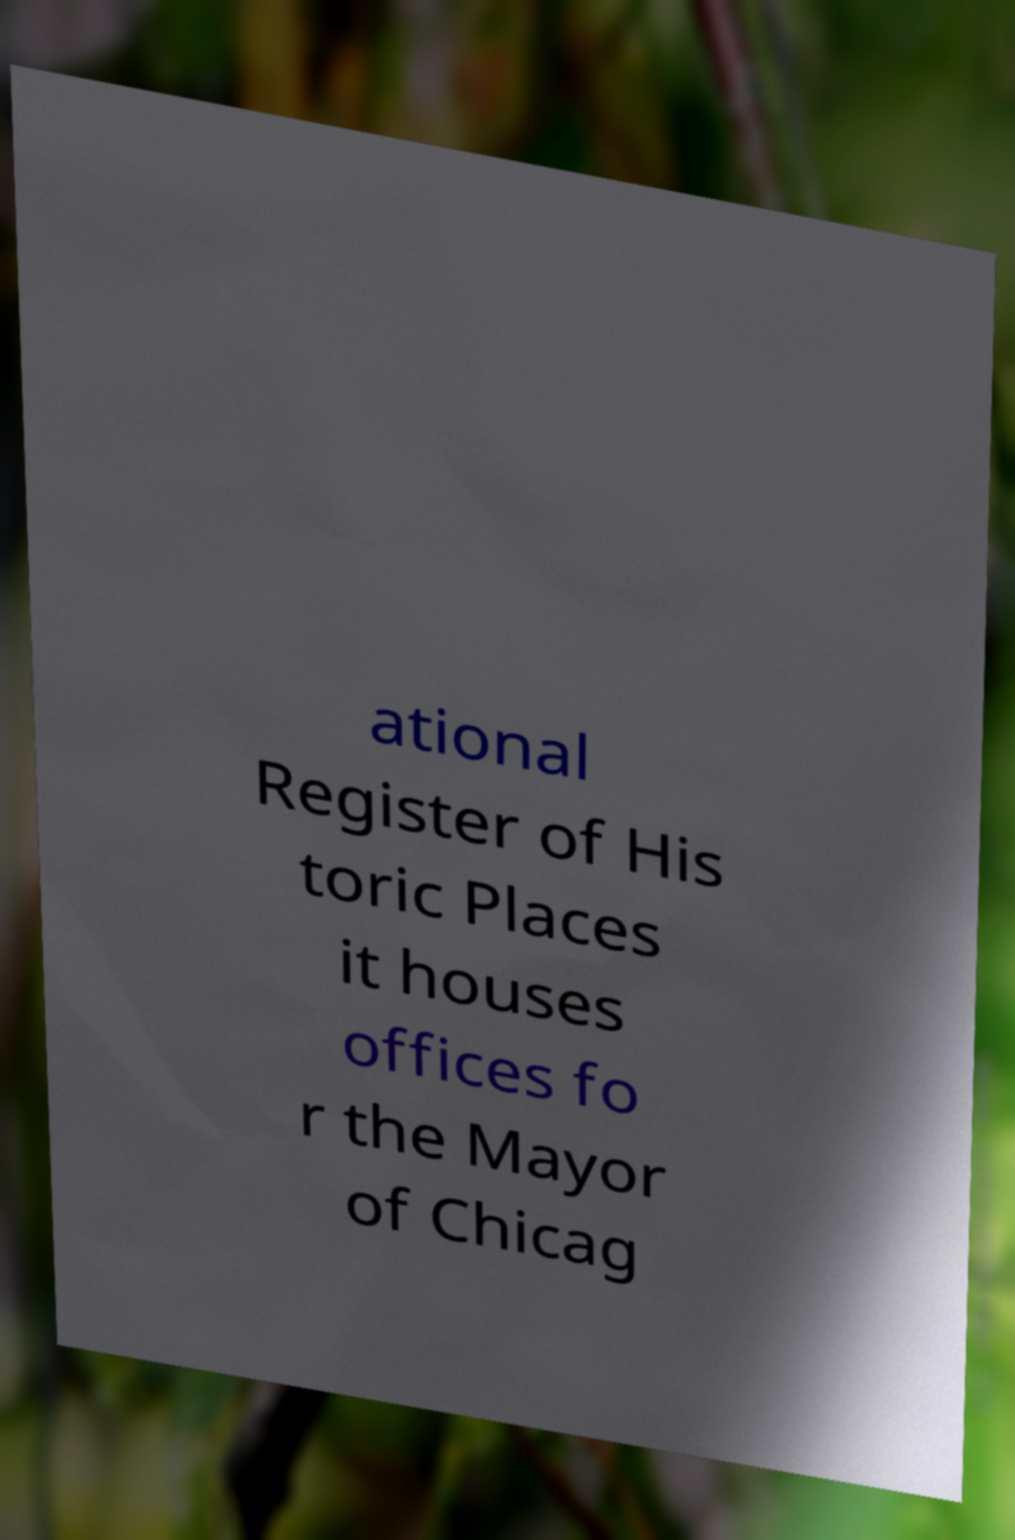There's text embedded in this image that I need extracted. Can you transcribe it verbatim? ational Register of His toric Places it houses offices fo r the Mayor of Chicag 